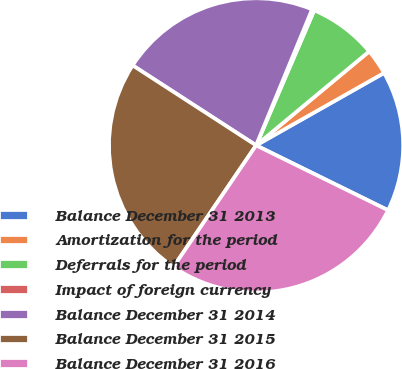Convert chart to OTSL. <chart><loc_0><loc_0><loc_500><loc_500><pie_chart><fcel>Balance December 31 2013<fcel>Amortization for the period<fcel>Deferrals for the period<fcel>Impact of foreign currency<fcel>Balance December 31 2014<fcel>Balance December 31 2015<fcel>Balance December 31 2016<nl><fcel>15.47%<fcel>2.84%<fcel>7.5%<fcel>0.25%<fcel>22.07%<fcel>24.65%<fcel>27.23%<nl></chart> 